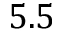<formula> <loc_0><loc_0><loc_500><loc_500>5 . 5</formula> 